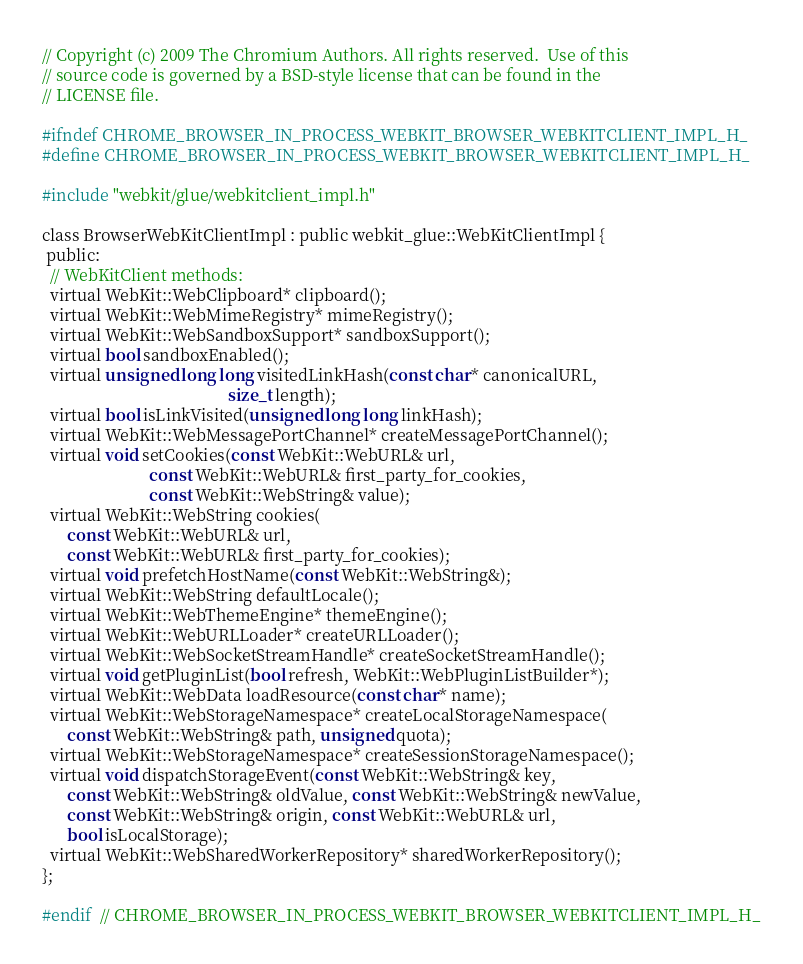Convert code to text. <code><loc_0><loc_0><loc_500><loc_500><_C_>// Copyright (c) 2009 The Chromium Authors. All rights reserved.  Use of this
// source code is governed by a BSD-style license that can be found in the
// LICENSE file.

#ifndef CHROME_BROWSER_IN_PROCESS_WEBKIT_BROWSER_WEBKITCLIENT_IMPL_H_
#define CHROME_BROWSER_IN_PROCESS_WEBKIT_BROWSER_WEBKITCLIENT_IMPL_H_

#include "webkit/glue/webkitclient_impl.h"

class BrowserWebKitClientImpl : public webkit_glue::WebKitClientImpl {
 public:
  // WebKitClient methods:
  virtual WebKit::WebClipboard* clipboard();
  virtual WebKit::WebMimeRegistry* mimeRegistry();
  virtual WebKit::WebSandboxSupport* sandboxSupport();
  virtual bool sandboxEnabled();
  virtual unsigned long long visitedLinkHash(const char* canonicalURL,
                                             size_t length);
  virtual bool isLinkVisited(unsigned long long linkHash);
  virtual WebKit::WebMessagePortChannel* createMessagePortChannel();
  virtual void setCookies(const WebKit::WebURL& url,
                          const WebKit::WebURL& first_party_for_cookies,
                          const WebKit::WebString& value);
  virtual WebKit::WebString cookies(
      const WebKit::WebURL& url,
      const WebKit::WebURL& first_party_for_cookies);
  virtual void prefetchHostName(const WebKit::WebString&);
  virtual WebKit::WebString defaultLocale();
  virtual WebKit::WebThemeEngine* themeEngine();
  virtual WebKit::WebURLLoader* createURLLoader();
  virtual WebKit::WebSocketStreamHandle* createSocketStreamHandle();
  virtual void getPluginList(bool refresh, WebKit::WebPluginListBuilder*);
  virtual WebKit::WebData loadResource(const char* name);
  virtual WebKit::WebStorageNamespace* createLocalStorageNamespace(
      const WebKit::WebString& path, unsigned quota);
  virtual WebKit::WebStorageNamespace* createSessionStorageNamespace();
  virtual void dispatchStorageEvent(const WebKit::WebString& key,
      const WebKit::WebString& oldValue, const WebKit::WebString& newValue,
      const WebKit::WebString& origin, const WebKit::WebURL& url,
      bool isLocalStorage);
  virtual WebKit::WebSharedWorkerRepository* sharedWorkerRepository();
};

#endif  // CHROME_BROWSER_IN_PROCESS_WEBKIT_BROWSER_WEBKITCLIENT_IMPL_H_
</code> 